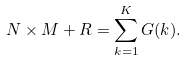Convert formula to latex. <formula><loc_0><loc_0><loc_500><loc_500>N \times M + R = \sum _ { k = 1 } ^ { K } G ( k ) .</formula> 